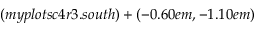<formula> <loc_0><loc_0><loc_500><loc_500>( m y p l o t s c 4 r 3 . s o u t h ) + ( - 0 . 6 0 e m , - 1 . 1 0 e m )</formula> 